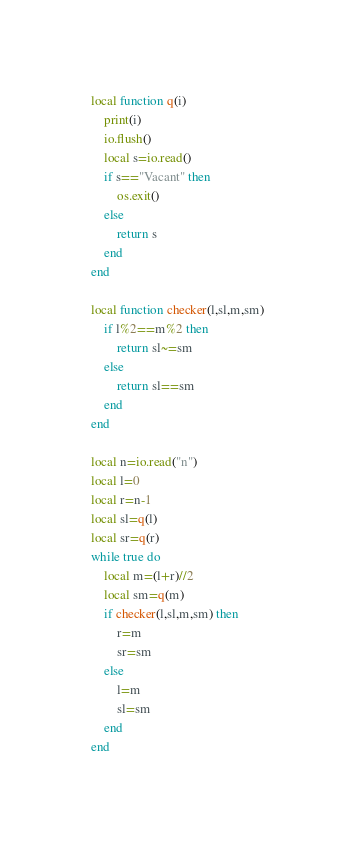<code> <loc_0><loc_0><loc_500><loc_500><_Lua_>local function q(i)
	print(i)
	io.flush()
	local s=io.read()
	if s=="Vacant" then
		os.exit()
	else
		return s
	end
end

local function checker(l,sl,m,sm)
    if l%2==m%2 then
		return sl~=sm
	else
		return sl==sm
	end
end

local n=io.read("n")
local l=0
local r=n-1
local sl=q(l)
local sr=q(r)
while true do
	local m=(l+r)//2
	local sm=q(m)
	if checker(l,sl,m,sm) then
		r=m
		sr=sm
	else
		l=m
		sl=sm
	end
end</code> 